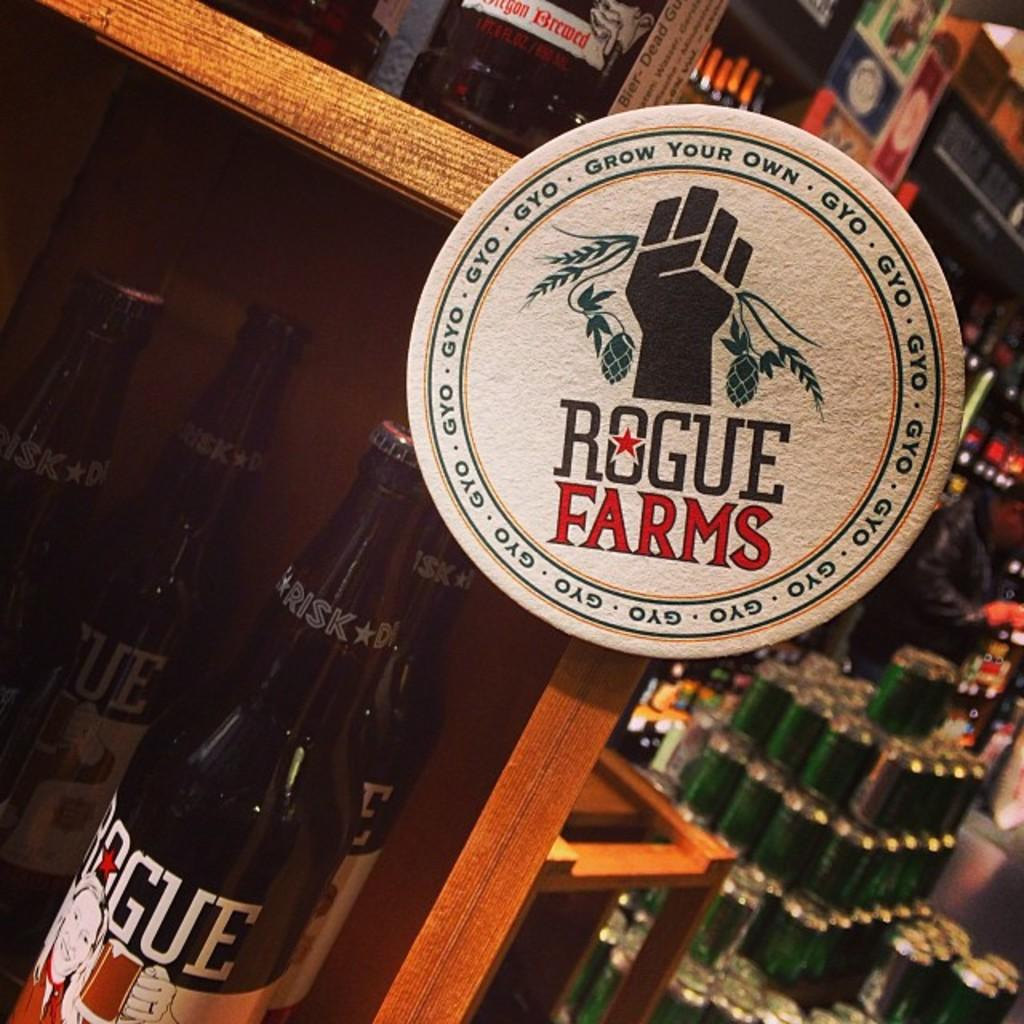<image>
Summarize the visual content of the image. A white label that has a logo of a company called Rogue Farms. 